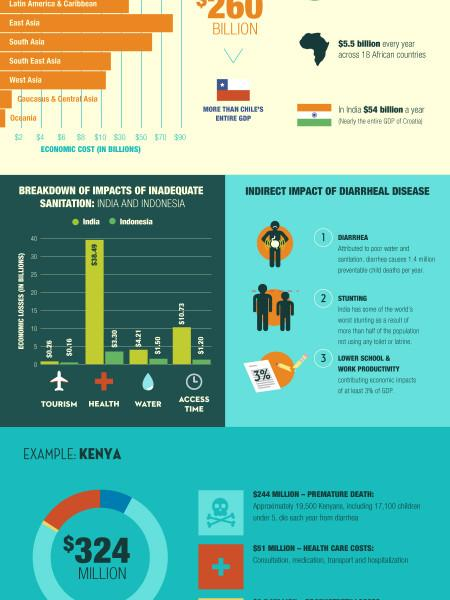List a handful of essential elements in this visual. India suffers a greater economic loss in the health sector than any other country. 